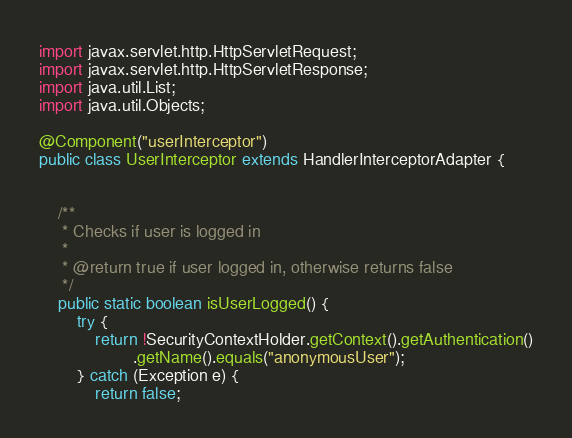Convert code to text. <code><loc_0><loc_0><loc_500><loc_500><_Java_>import javax.servlet.http.HttpServletRequest;
import javax.servlet.http.HttpServletResponse;
import java.util.List;
import java.util.Objects;

@Component("userInterceptor")
public class UserInterceptor extends HandlerInterceptorAdapter {


    /**
     * Checks if user is logged in
     *
     * @return true if user logged in, otherwise returns false
     */
    public static boolean isUserLogged() {
        try {
            return !SecurityContextHolder.getContext().getAuthentication()
                    .getName().equals("anonymousUser");
        } catch (Exception e) {
            return false;</code> 